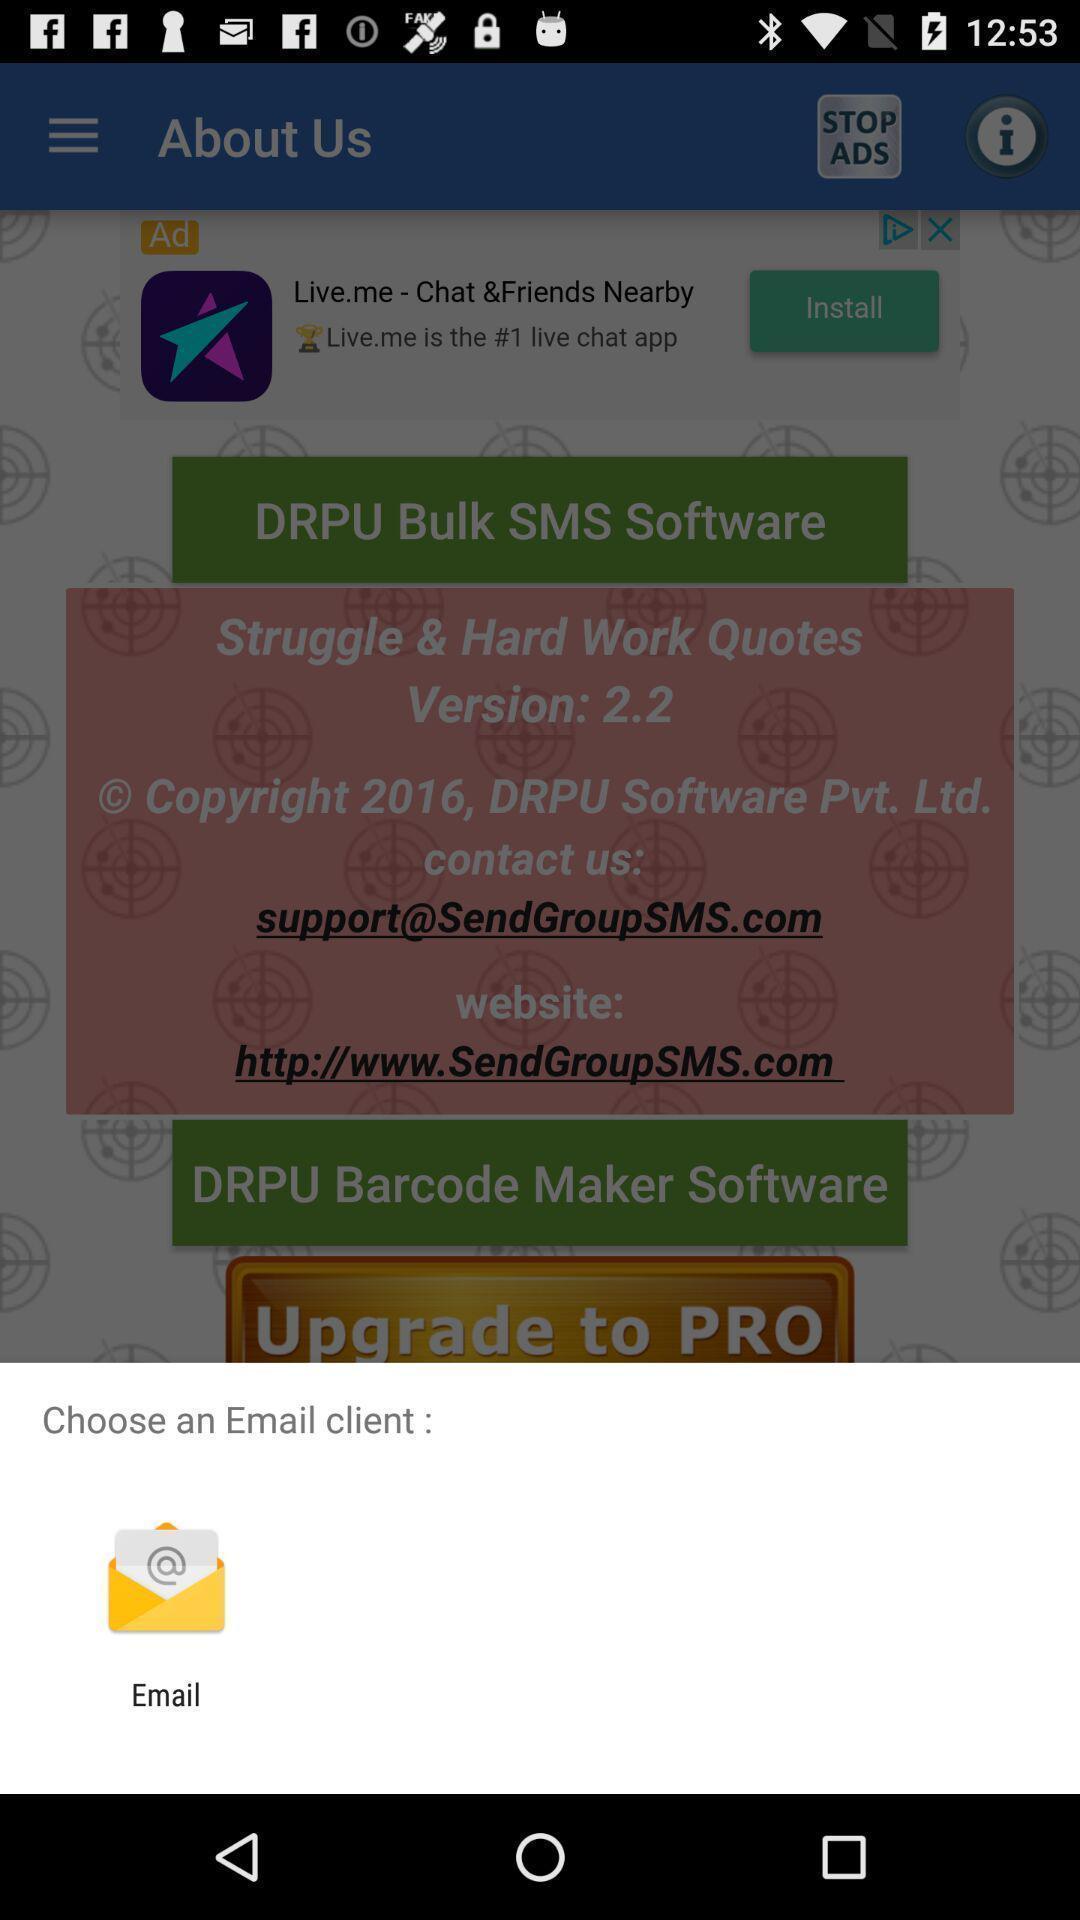What is the overall content of this screenshot? Pop-up to choose an email client via mail. 